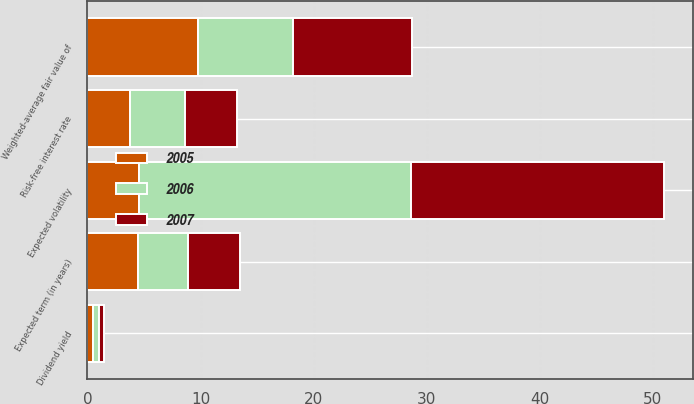<chart> <loc_0><loc_0><loc_500><loc_500><stacked_bar_chart><ecel><fcel>Dividend yield<fcel>Expected volatility<fcel>Risk-free interest rate<fcel>Expected term (in years)<fcel>Weighted-average fair value of<nl><fcel>2007<fcel>0.5<fcel>22.4<fcel>4.6<fcel>4.6<fcel>10.52<nl><fcel>2006<fcel>0.5<fcel>24<fcel>4.8<fcel>4.4<fcel>8.33<nl><fcel>2005<fcel>0.5<fcel>4.6<fcel>3.8<fcel>4.5<fcel>9.81<nl></chart> 